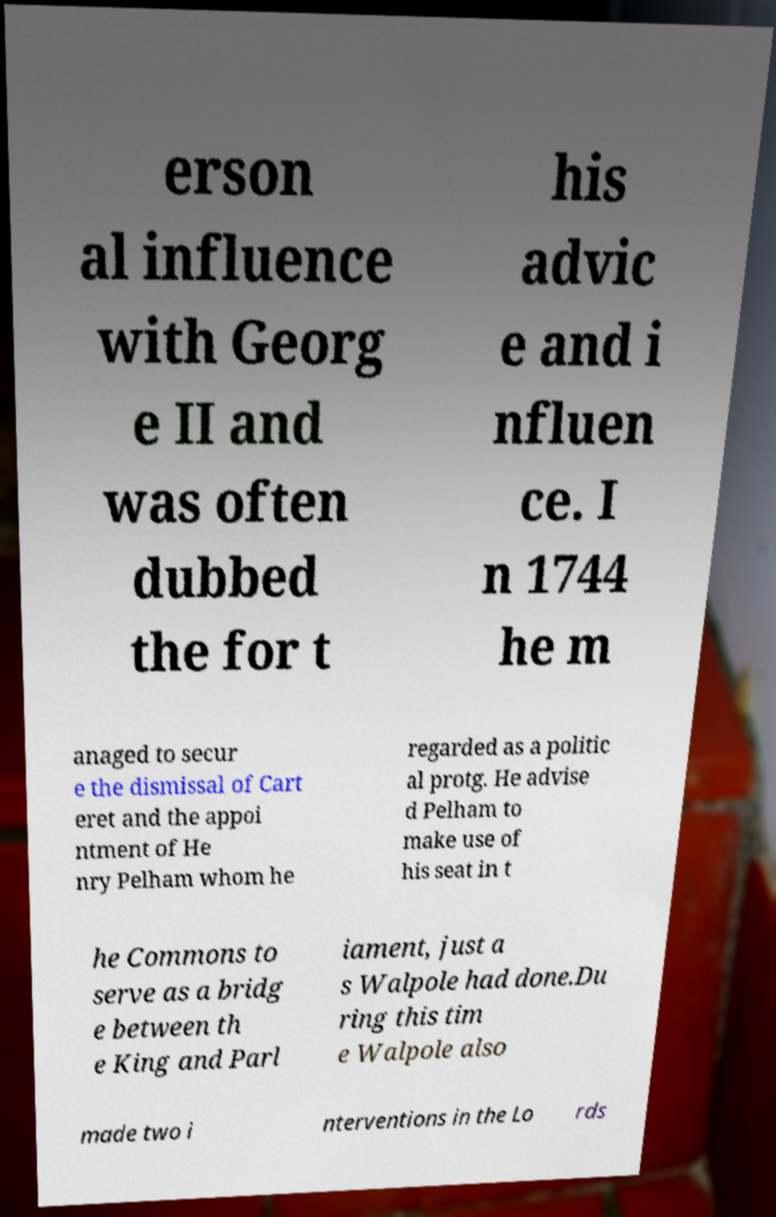Can you accurately transcribe the text from the provided image for me? erson al influence with Georg e II and was often dubbed the for t his advic e and i nfluen ce. I n 1744 he m anaged to secur e the dismissal of Cart eret and the appoi ntment of He nry Pelham whom he regarded as a politic al protg. He advise d Pelham to make use of his seat in t he Commons to serve as a bridg e between th e King and Parl iament, just a s Walpole had done.Du ring this tim e Walpole also made two i nterventions in the Lo rds 